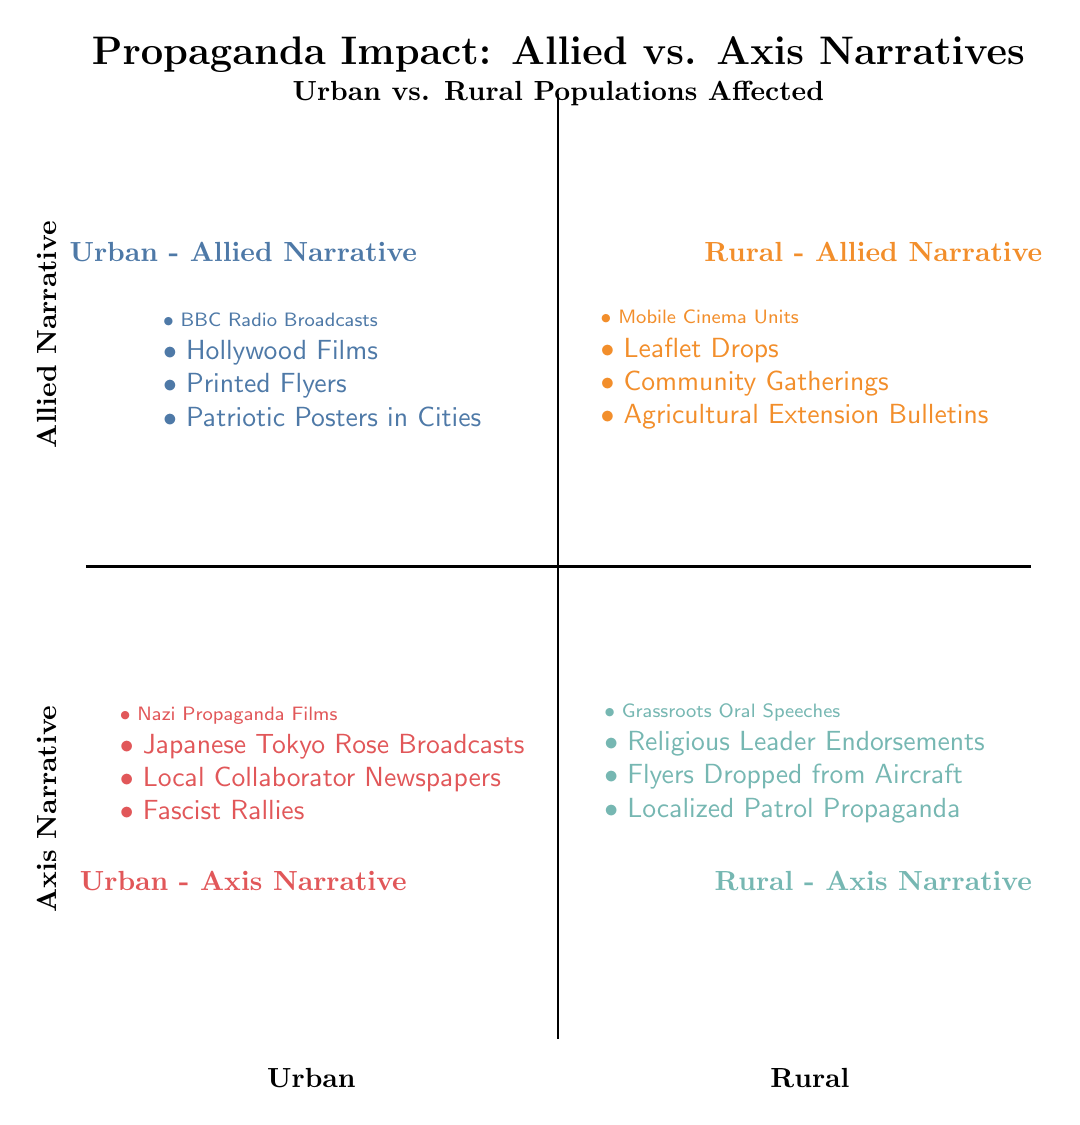What narratives are represented in the Urban - Allied Quadrant? The Urban - Allied Quadrant features four propaganda methods: BBC Radio Broadcasts, Hollywood Films, Printed Flyers, and Patriotic Posters in Cities. These methods are listed directly within the quadrant area of the diagram.
Answer: BBC Radio Broadcasts, Hollywood Films, Printed Flyers, Patriotic Posters in Cities How many propaganda methods are shown in the Rural - Axis Quadrant? The Rural - Axis Quadrant includes four distinct methods: Grassroots Oral Speeches, Religious Leader Endorsements, Flyers Dropped from Aircraft, and Localized Patrol Propaganda. Thus, there are four methods in this quadrant.
Answer: 4 Which quadrant has Nazi Propaganda Films as a method? Nazi Propaganda Films are located in the Urban - Axis Narrative Quadrant, as indicated clearly in the diagram where this method is explicitly associated with the Urban and Axis narratives.
Answer: Urban - Axis Narrative What type of gatherings are mentioned in the Rural - Allied Quadrant? The Rural - Allied Quadrant mentions Community Gatherings as an important type of propaganda activity in rural settings, highlighting community-oriented approaches to information dissemination.
Answer: Community Gatherings Which narrative uses Local Collaborator Newspapers? Local Collaborator Newspapers are associated with the Urban - Axis Narrative, indicating this method of propaganda was employed in urban settings by Axis powers, as indicated in the diagram.
Answer: Urban - Axis Narrative What is the primary medium of propaganda in Urban - Allied narratives? The primary mediums of propaganda in the Urban - Allied Narratives include BBC Radio Broadcasts and Hollywood Films, both of which utilize media outreach most effectively in urban centers.
Answer: BBC Radio Broadcasts, Hollywood Films How do the propaganda methods differ between Urban and Rural settings for Allied narratives? In the Allied narratives, Urban settings utilize methods focused on mass media like BBC Radio and Hollywood Films, while Rural settings emphasize on-the-ground approaches like Mobile Cinema Units and Community Gatherings, showcasing a strategic contrast influenced by geography.
Answer: Different media outreach methods What role do Religious Leader Endorsements play in the Rural - Axis narrative? Religious Leader Endorsements serve as a social authority figure source to lend credibility to Axis narratives in rural areas, indicating the local level engagement and influence of religious institutions in propaganda.
Answer: Credibility source for propaganda 